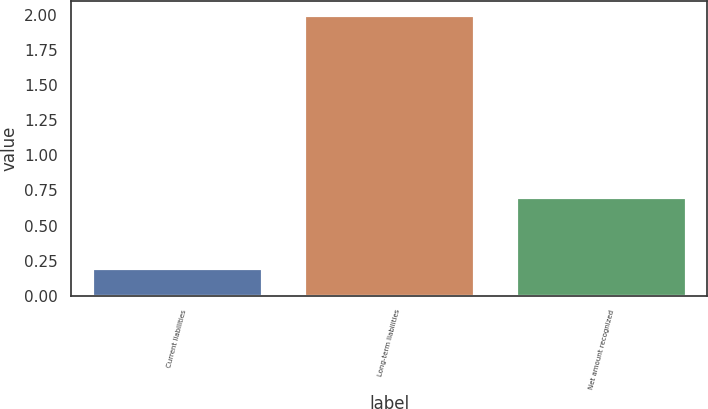Convert chart to OTSL. <chart><loc_0><loc_0><loc_500><loc_500><bar_chart><fcel>Current liabilities<fcel>Long-term liabilities<fcel>Net amount recognized<nl><fcel>0.2<fcel>2<fcel>0.7<nl></chart> 